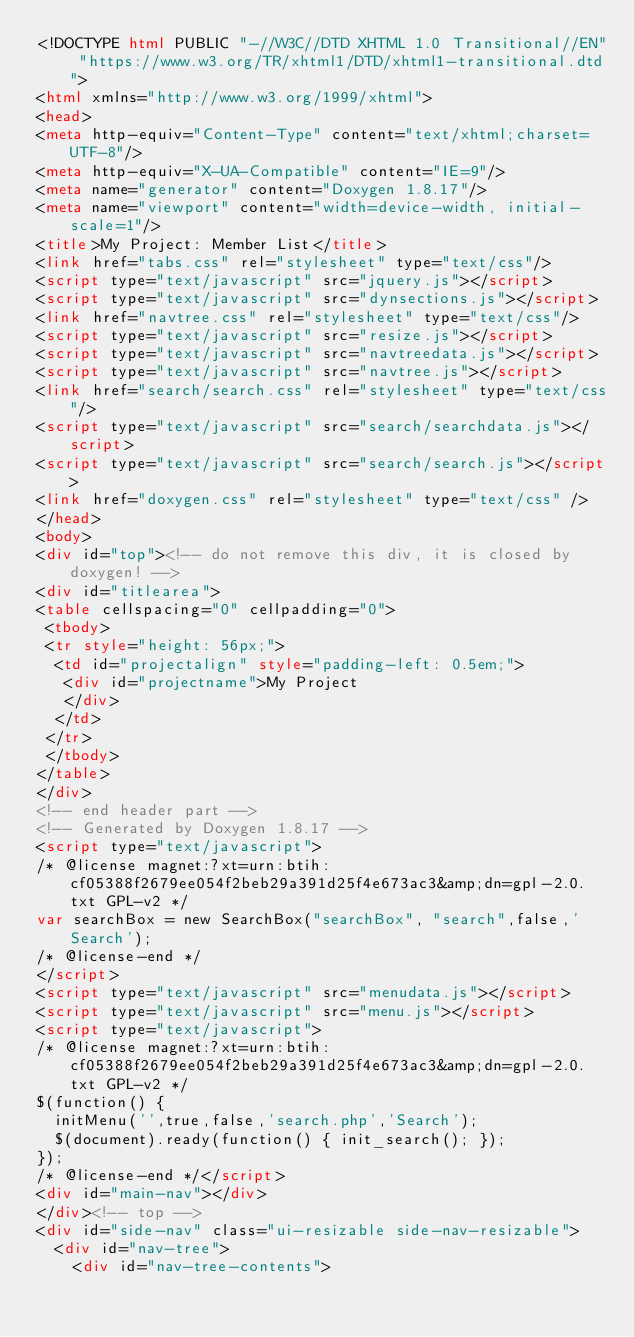<code> <loc_0><loc_0><loc_500><loc_500><_HTML_><!DOCTYPE html PUBLIC "-//W3C//DTD XHTML 1.0 Transitional//EN" "https://www.w3.org/TR/xhtml1/DTD/xhtml1-transitional.dtd">
<html xmlns="http://www.w3.org/1999/xhtml">
<head>
<meta http-equiv="Content-Type" content="text/xhtml;charset=UTF-8"/>
<meta http-equiv="X-UA-Compatible" content="IE=9"/>
<meta name="generator" content="Doxygen 1.8.17"/>
<meta name="viewport" content="width=device-width, initial-scale=1"/>
<title>My Project: Member List</title>
<link href="tabs.css" rel="stylesheet" type="text/css"/>
<script type="text/javascript" src="jquery.js"></script>
<script type="text/javascript" src="dynsections.js"></script>
<link href="navtree.css" rel="stylesheet" type="text/css"/>
<script type="text/javascript" src="resize.js"></script>
<script type="text/javascript" src="navtreedata.js"></script>
<script type="text/javascript" src="navtree.js"></script>
<link href="search/search.css" rel="stylesheet" type="text/css"/>
<script type="text/javascript" src="search/searchdata.js"></script>
<script type="text/javascript" src="search/search.js"></script>
<link href="doxygen.css" rel="stylesheet" type="text/css" />
</head>
<body>
<div id="top"><!-- do not remove this div, it is closed by doxygen! -->
<div id="titlearea">
<table cellspacing="0" cellpadding="0">
 <tbody>
 <tr style="height: 56px;">
  <td id="projectalign" style="padding-left: 0.5em;">
   <div id="projectname">My Project
   </div>
  </td>
 </tr>
 </tbody>
</table>
</div>
<!-- end header part -->
<!-- Generated by Doxygen 1.8.17 -->
<script type="text/javascript">
/* @license magnet:?xt=urn:btih:cf05388f2679ee054f2beb29a391d25f4e673ac3&amp;dn=gpl-2.0.txt GPL-v2 */
var searchBox = new SearchBox("searchBox", "search",false,'Search');
/* @license-end */
</script>
<script type="text/javascript" src="menudata.js"></script>
<script type="text/javascript" src="menu.js"></script>
<script type="text/javascript">
/* @license magnet:?xt=urn:btih:cf05388f2679ee054f2beb29a391d25f4e673ac3&amp;dn=gpl-2.0.txt GPL-v2 */
$(function() {
  initMenu('',true,false,'search.php','Search');
  $(document).ready(function() { init_search(); });
});
/* @license-end */</script>
<div id="main-nav"></div>
</div><!-- top -->
<div id="side-nav" class="ui-resizable side-nav-resizable">
  <div id="nav-tree">
    <div id="nav-tree-contents"></code> 